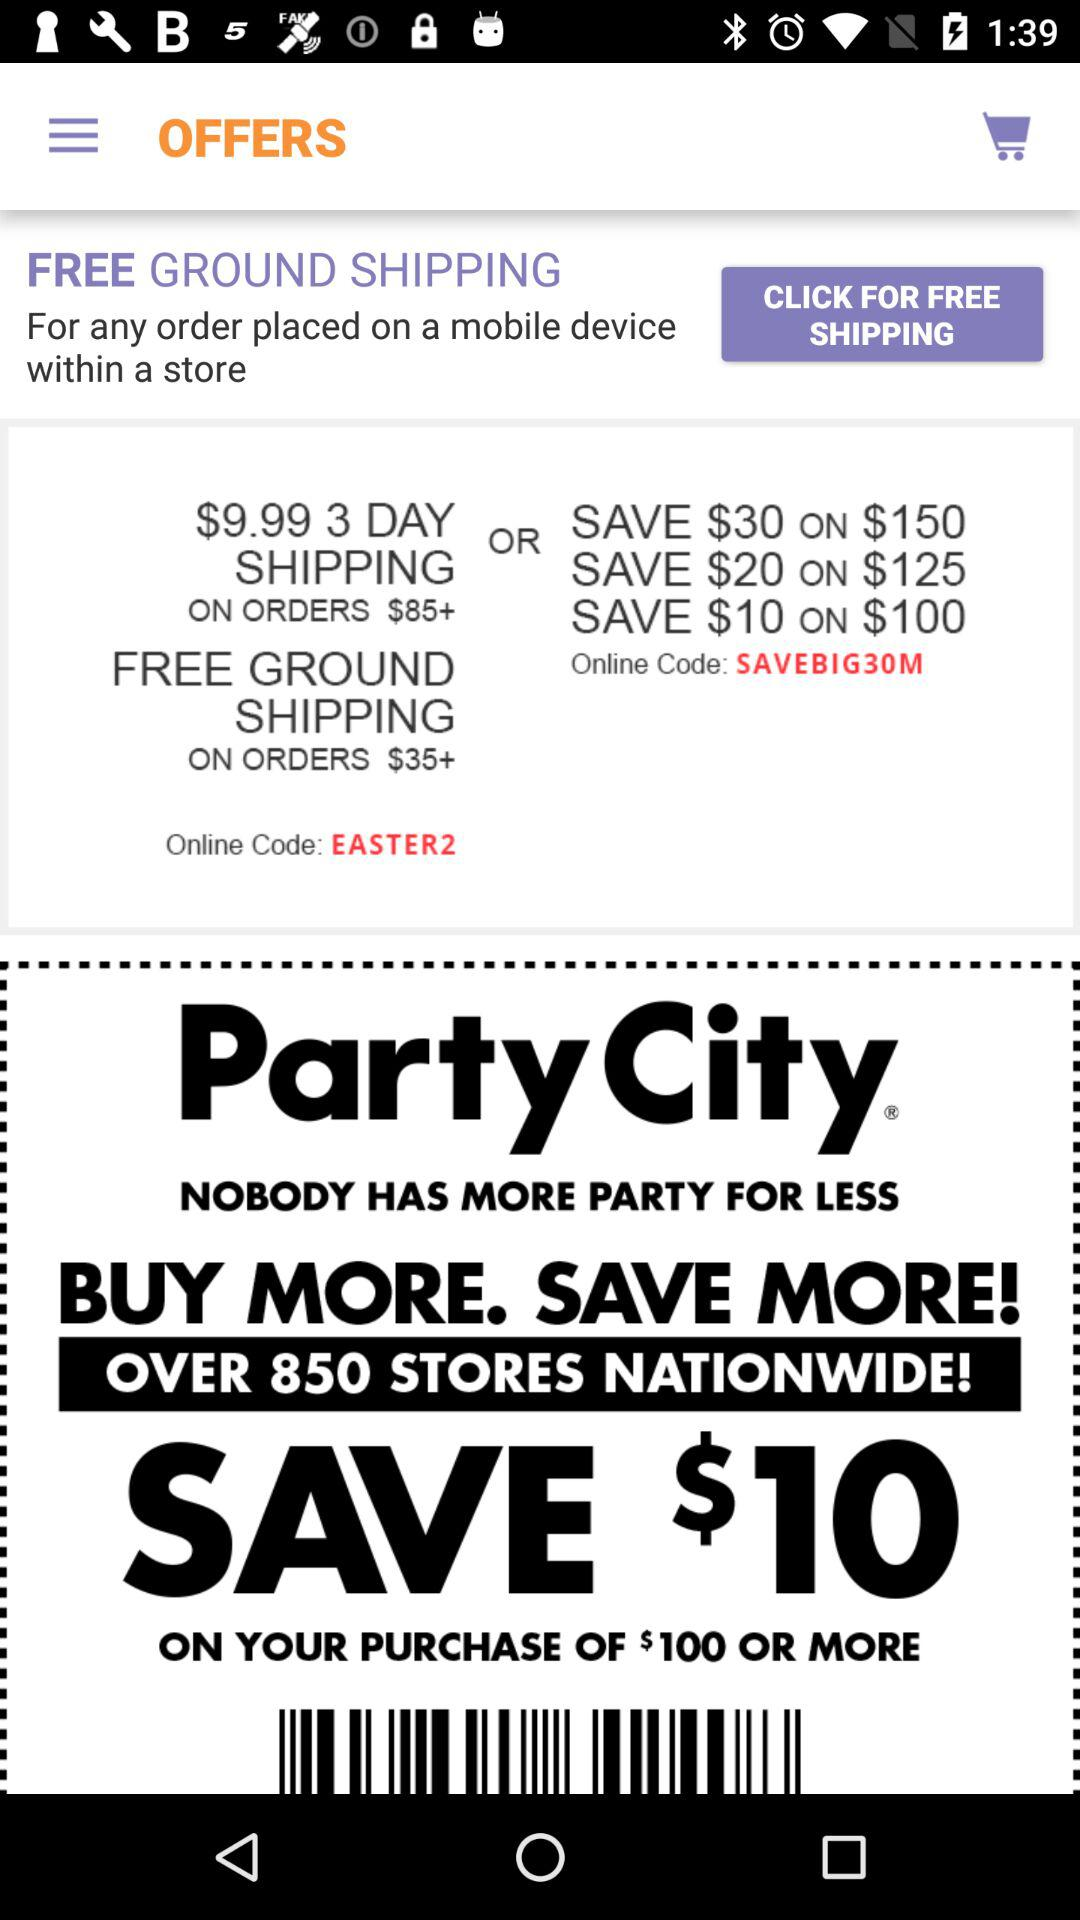How many number of stores are giving offers nationwide?
When the provided information is insufficient, respond with <no answer>. <no answer> 